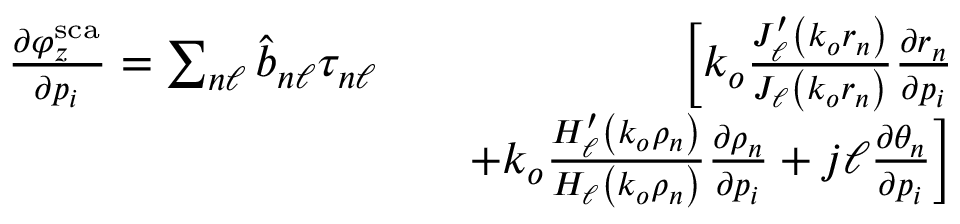Convert formula to latex. <formula><loc_0><loc_0><loc_500><loc_500>\begin{array} { r l r } { \frac { \partial \varphi _ { z } ^ { s c a } } { \partial p _ { i } } = \sum _ { n \ell } \hat { b } _ { n \ell } \tau _ { n \ell } } & { \left [ k _ { o } \frac { J _ { \ell } ^ { \prime } \left ( k _ { o } r _ { n } \right ) } { J _ { \ell } \left ( k _ { o } r _ { n } \right ) } \frac { \partial r _ { n } } { \partial p _ { i } } } \\ & { + k _ { o } \frac { H _ { \ell } ^ { \prime } \left ( k _ { o } \rho _ { n } \right ) } { H _ { \ell } \left ( k _ { o } \rho _ { n } \right ) } \frac { \partial \rho _ { n } } { \partial p _ { i } } + j \ell \frac { \partial \theta _ { n } } { \partial p _ { i } } \right ] } \end{array}</formula> 